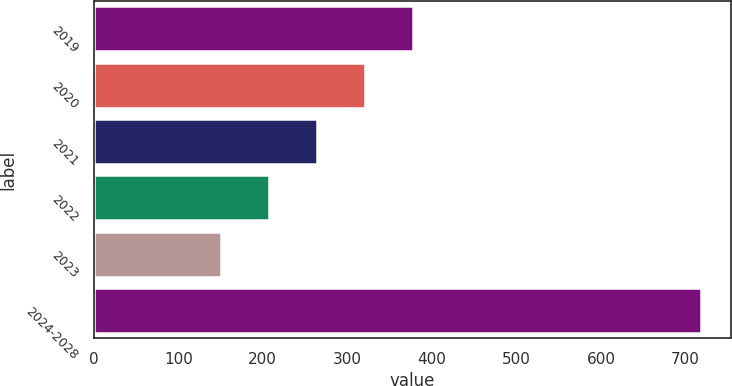<chart> <loc_0><loc_0><loc_500><loc_500><bar_chart><fcel>2019<fcel>2020<fcel>2021<fcel>2022<fcel>2023<fcel>2024-2028<nl><fcel>377.8<fcel>321.1<fcel>264.4<fcel>207.7<fcel>151<fcel>718<nl></chart> 